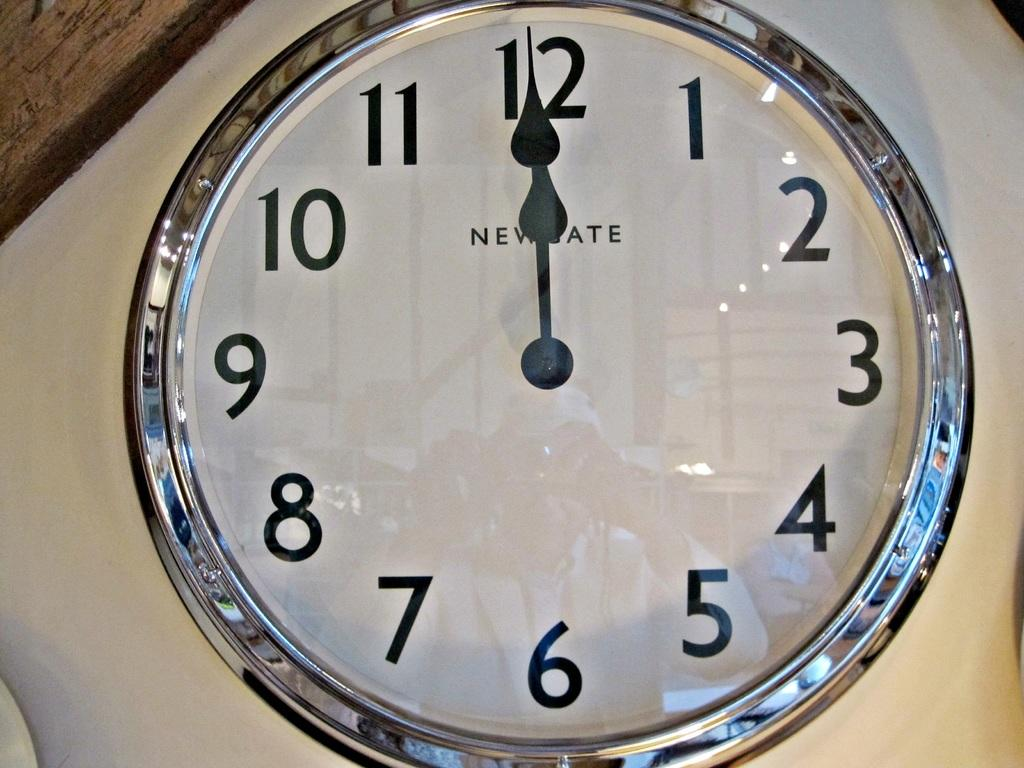What object in the image tells the time? There is a clock in the image that tells the time. What is the color of the surface on which the clock is placed? The clock is on a white surface. What type of snake is crawling on the clock in the image? There is no snake present in the image; it only features a clock on a white surface. 